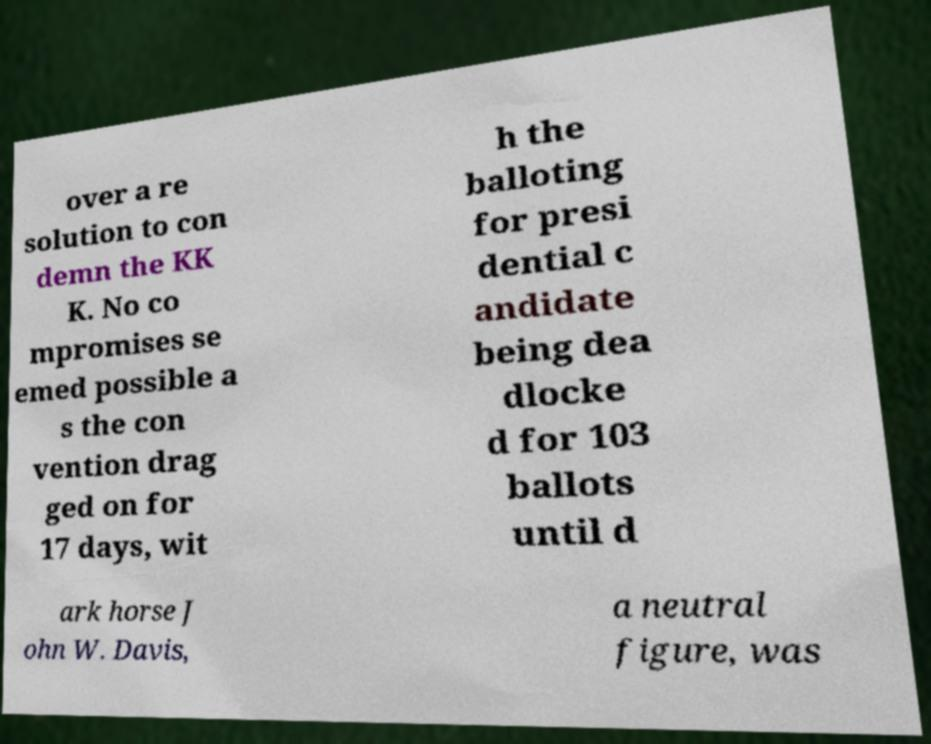For documentation purposes, I need the text within this image transcribed. Could you provide that? over a re solution to con demn the KK K. No co mpromises se emed possible a s the con vention drag ged on for 17 days, wit h the balloting for presi dential c andidate being dea dlocke d for 103 ballots until d ark horse J ohn W. Davis, a neutral figure, was 